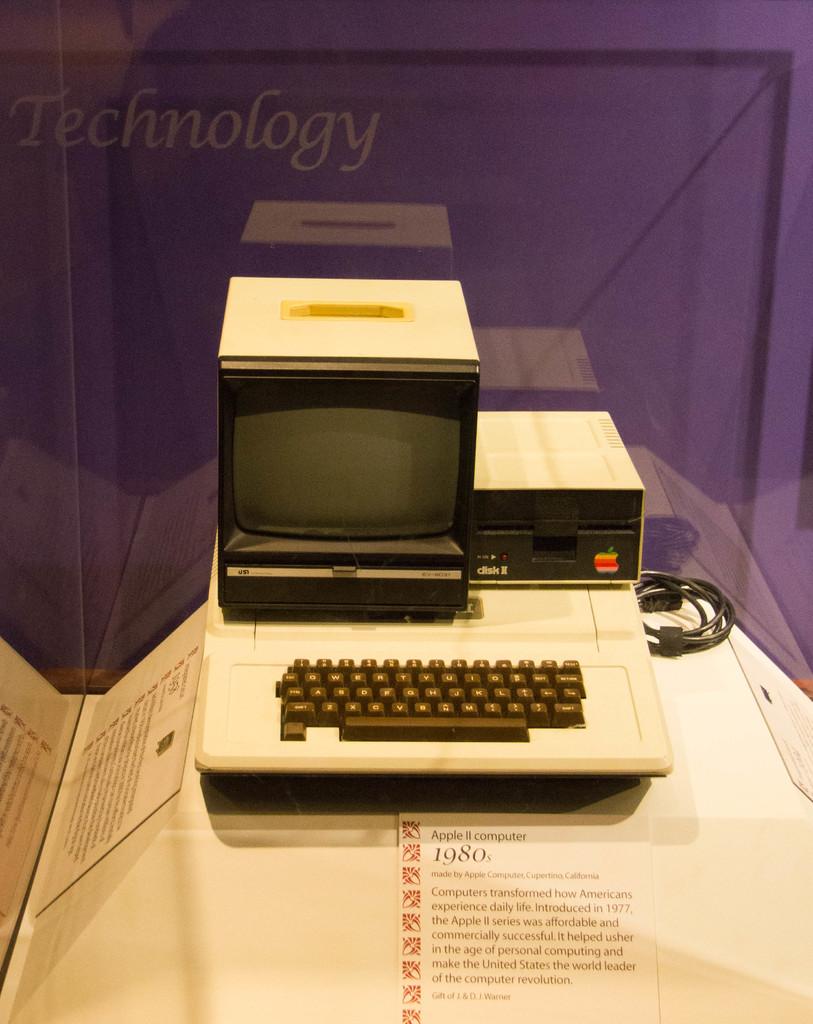When was this computer released?
Your response must be concise. 1980. 